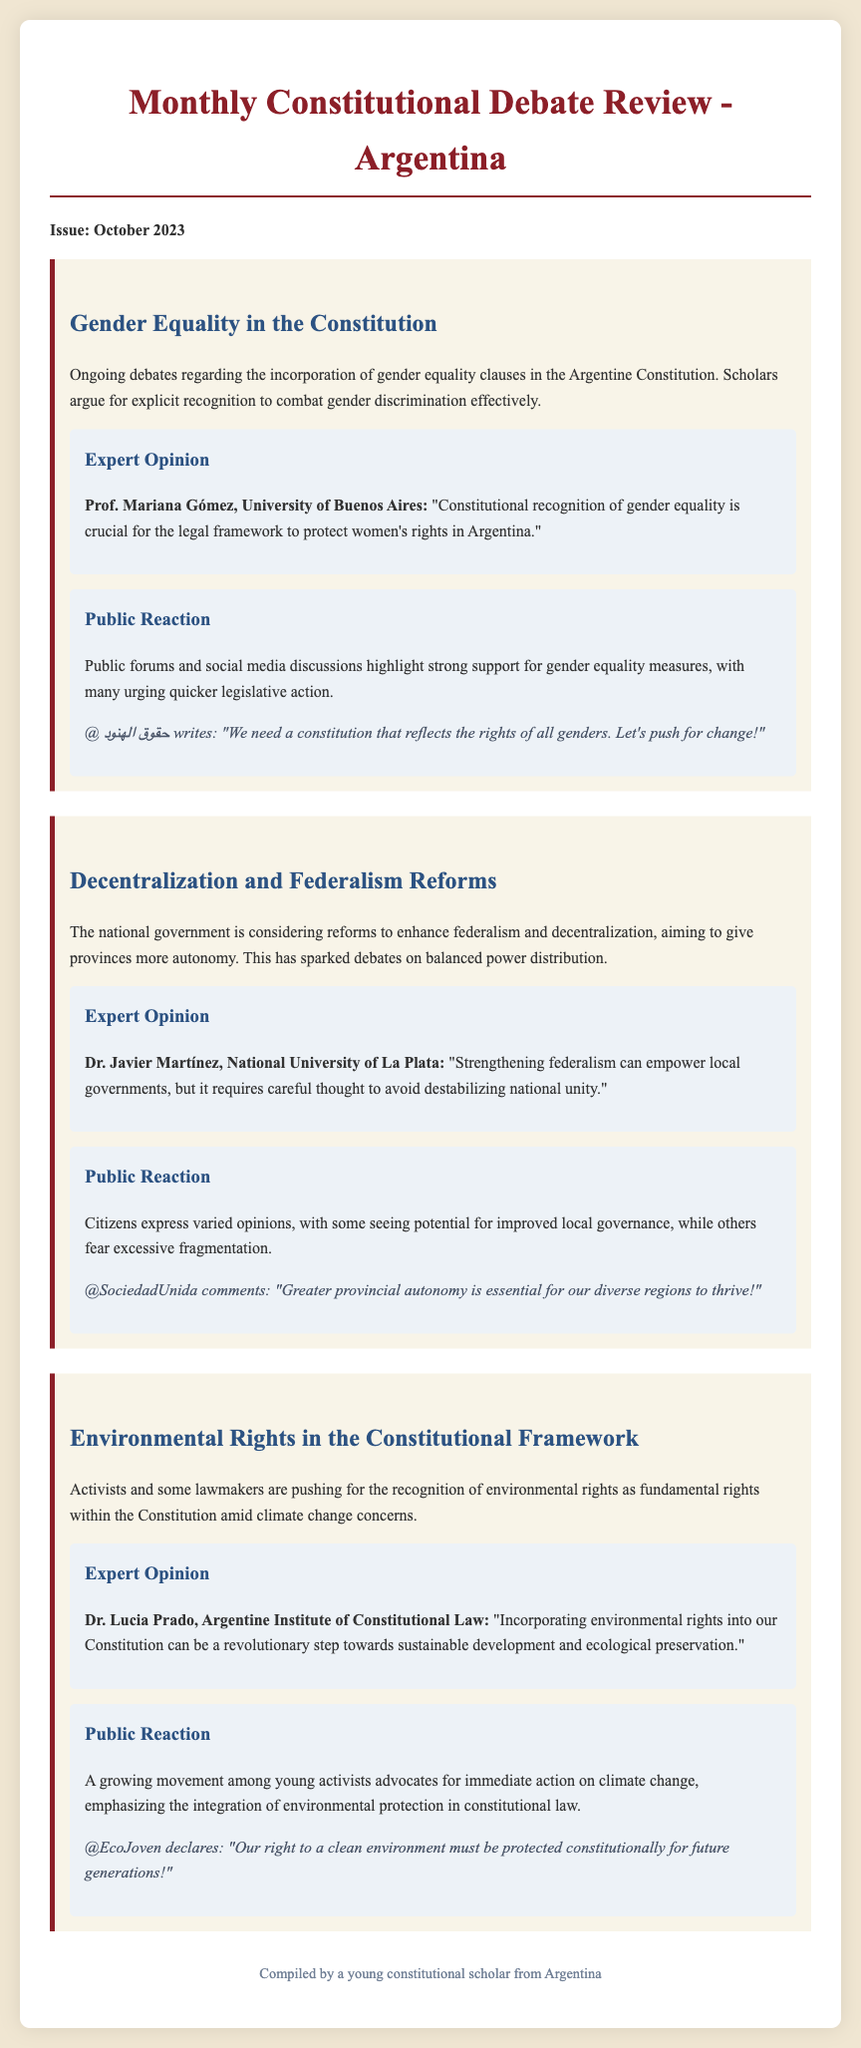What is the title of the newsletter? The title is provided at the top of the document in a prominent heading format.
Answer: Monthly Constitutional Debate Review - Argentina Who is the expert quoted on gender equality? The document mentions experts who provide their opinions on various topics.
Answer: Prof. Mariana Gómez What is one of the topics discussed in the October 2023 issue? Several topics are listed in the document's sections, each representing a current debate or reform.
Answer: Gender Equality in the Constitution What date is the newsletter issue published? The publication date is stated clearly in the opening paragraph of the document.
Answer: October 2023 Which expert focuses on environmental rights? The experts cited in the document provide insight into current debates, particularly related to their respective fields.
Answer: Dr. Lucia Prado What concern is raised about federalism reforms? The document outlines differing opinions on the proposed reforms, indicating various public sentiments.
Answer: Excessive fragmentation What social media post highlights the need for gender equality? The document includes public reactions and representative comments reflecting the ongoing discussions.
Answer: @ حقوق الهنود writes: "We need a constitution that reflects the rights of all genders. Let's push for change!" How many expert opinions are provided in the newsletter? The newsletter features expert commentary accompanying each of the highlighted topics discussed throughout the issue.
Answer: Three What is a key theme of the public reaction concerning environmental rights? The document describes the public response related to environmental issues and the urgency surrounding them.
Answer: Immediate action on climate change 